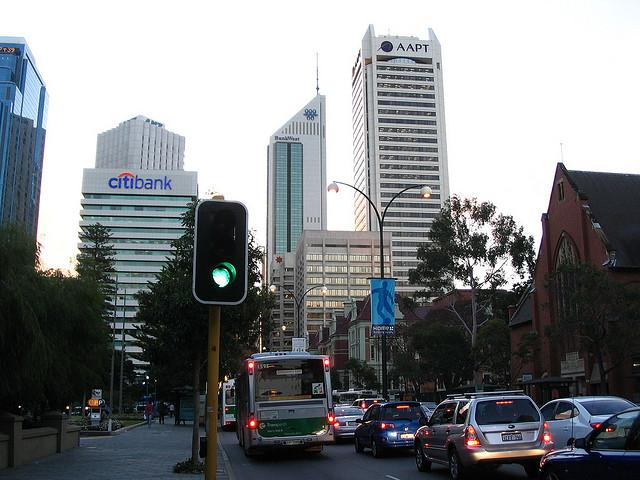Who designed the first building's logo?

Choices:
A) maurice finn
B) doug thomas
C) beth finkelstein
D) paula scher paula scher 